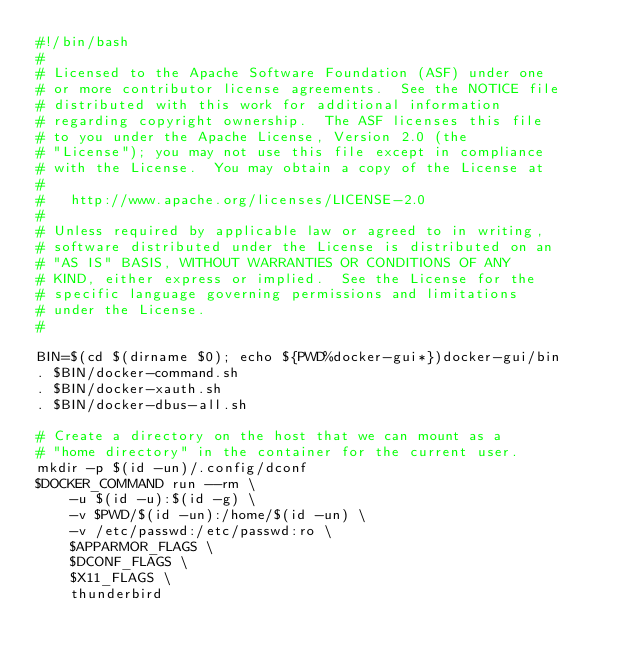<code> <loc_0><loc_0><loc_500><loc_500><_Bash_>#!/bin/bash
#
# Licensed to the Apache Software Foundation (ASF) under one
# or more contributor license agreements.  See the NOTICE file
# distributed with this work for additional information
# regarding copyright ownership.  The ASF licenses this file
# to you under the Apache License, Version 2.0 (the
# "License"); you may not use this file except in compliance
# with the License.  You may obtain a copy of the License at
# 
#   http://www.apache.org/licenses/LICENSE-2.0
# 
# Unless required by applicable law or agreed to in writing,
# software distributed under the License is distributed on an
# "AS IS" BASIS, WITHOUT WARRANTIES OR CONDITIONS OF ANY
# KIND, either express or implied.  See the License for the
# specific language governing permissions and limitations
# under the License.
#

BIN=$(cd $(dirname $0); echo ${PWD%docker-gui*})docker-gui/bin
. $BIN/docker-command.sh
. $BIN/docker-xauth.sh
. $BIN/docker-dbus-all.sh

# Create a directory on the host that we can mount as a
# "home directory" in the container for the current user. 
mkdir -p $(id -un)/.config/dconf
$DOCKER_COMMAND run --rm \
    -u $(id -u):$(id -g) \
    -v $PWD/$(id -un):/home/$(id -un) \
    -v /etc/passwd:/etc/passwd:ro \
    $APPARMOR_FLAGS \
    $DCONF_FLAGS \
    $X11_FLAGS \
    thunderbird

</code> 